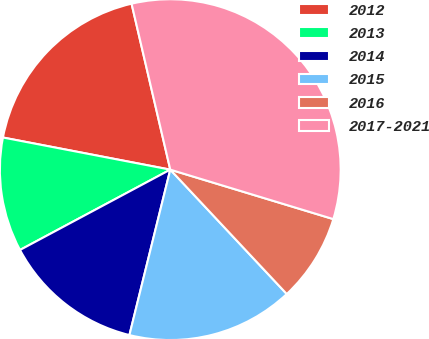Convert chart to OTSL. <chart><loc_0><loc_0><loc_500><loc_500><pie_chart><fcel>2012<fcel>2013<fcel>2014<fcel>2015<fcel>2016<fcel>2017-2021<nl><fcel>18.33%<fcel>10.83%<fcel>13.33%<fcel>15.83%<fcel>8.33%<fcel>33.33%<nl></chart> 